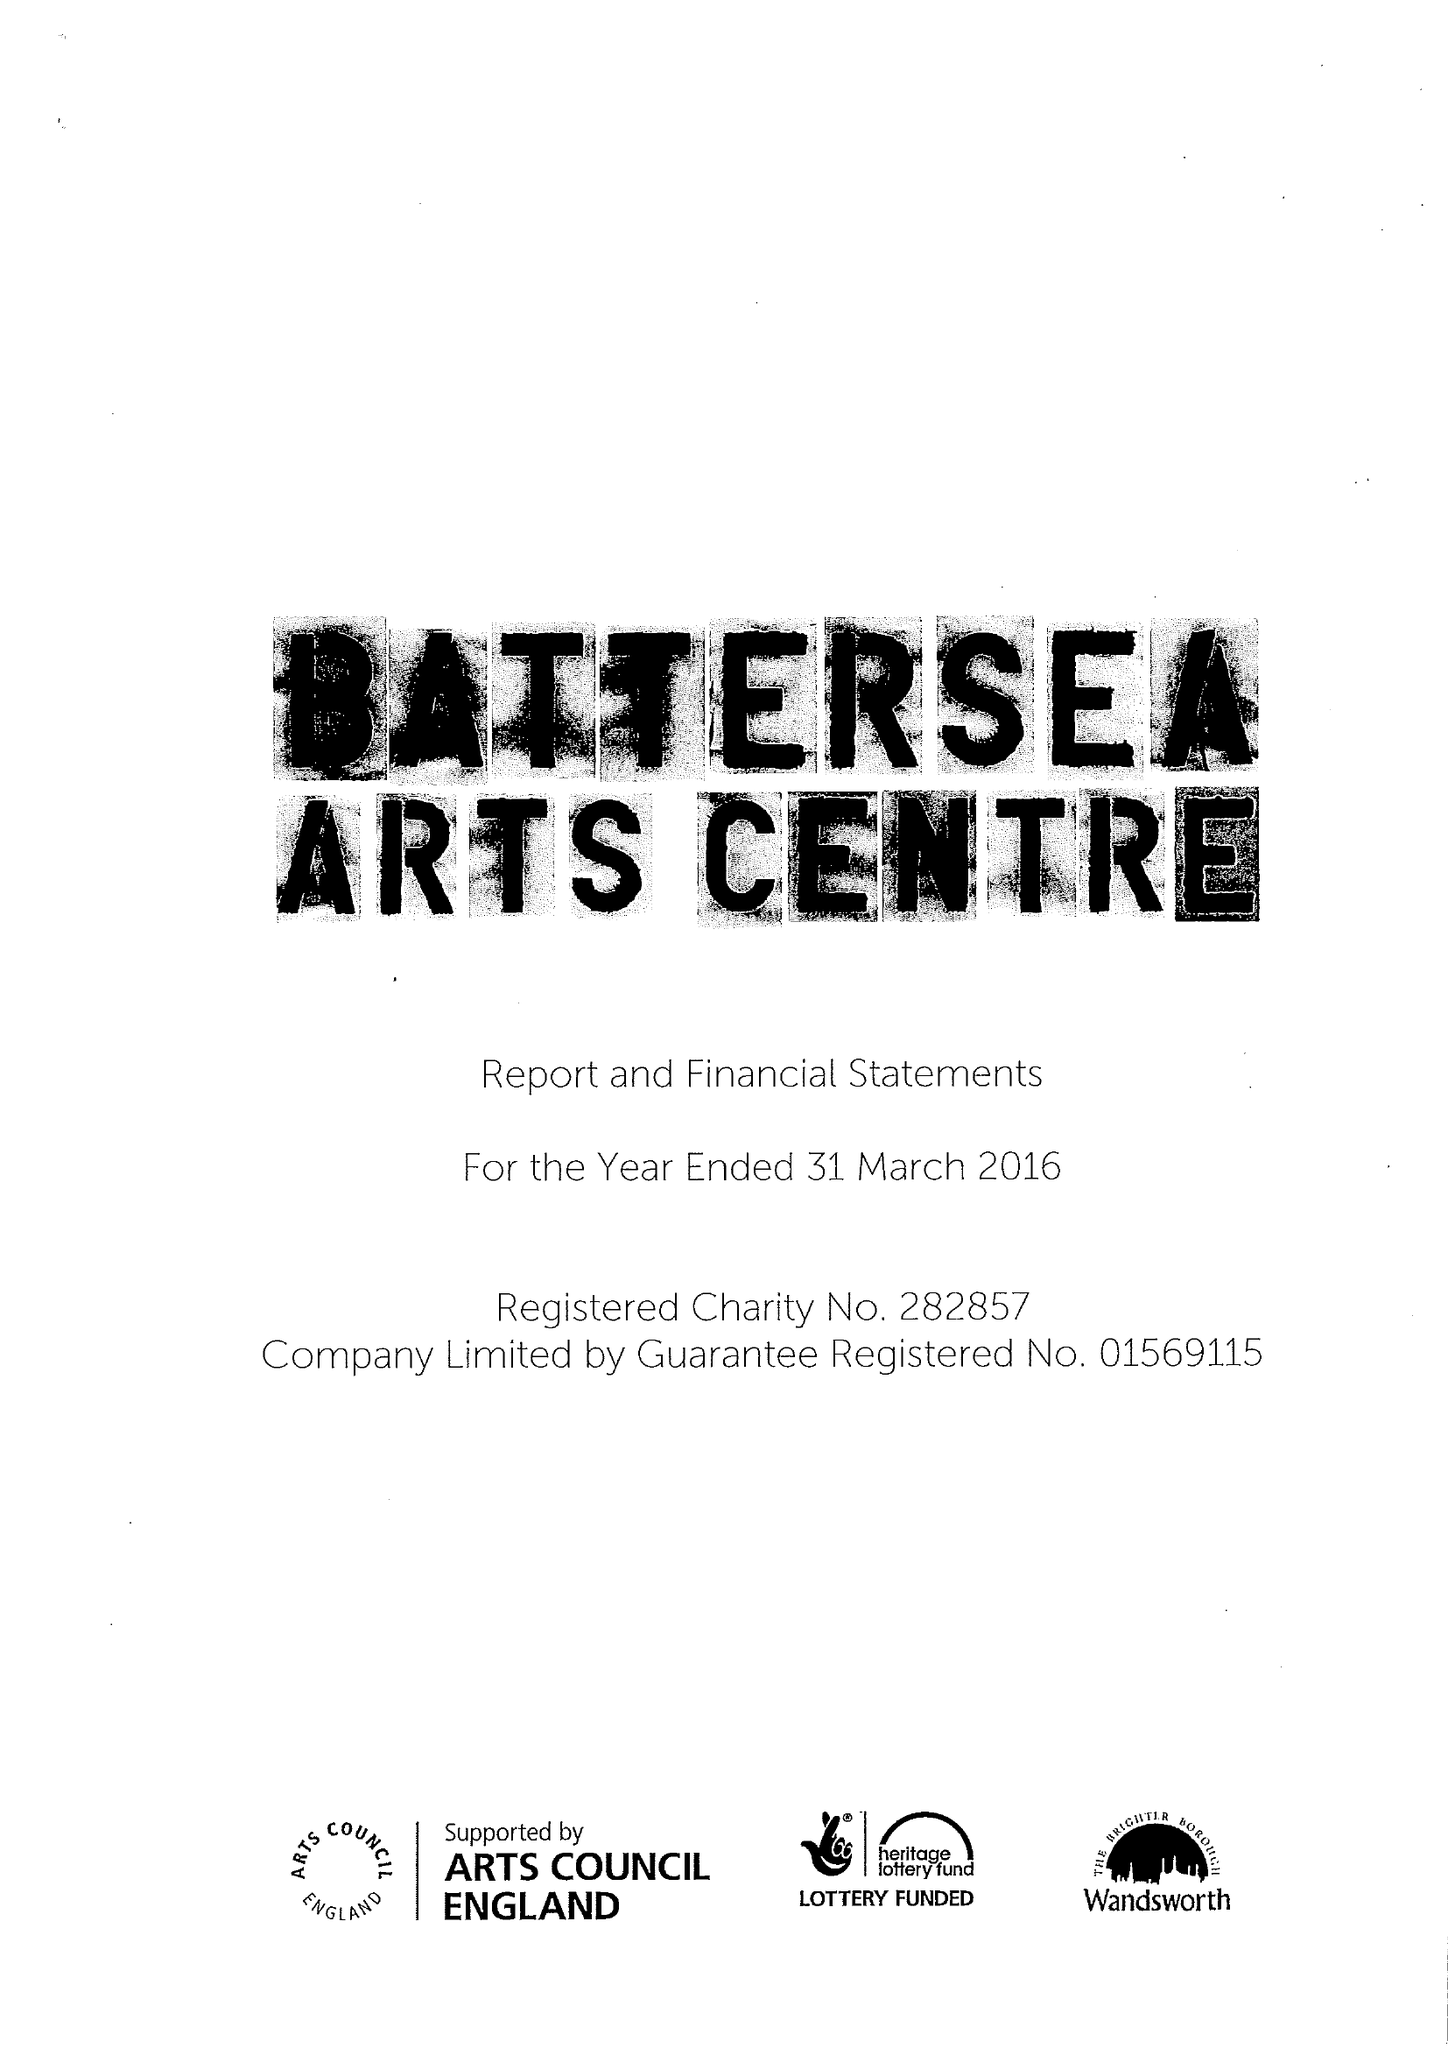What is the value for the charity_number?
Answer the question using a single word or phrase. 282857 